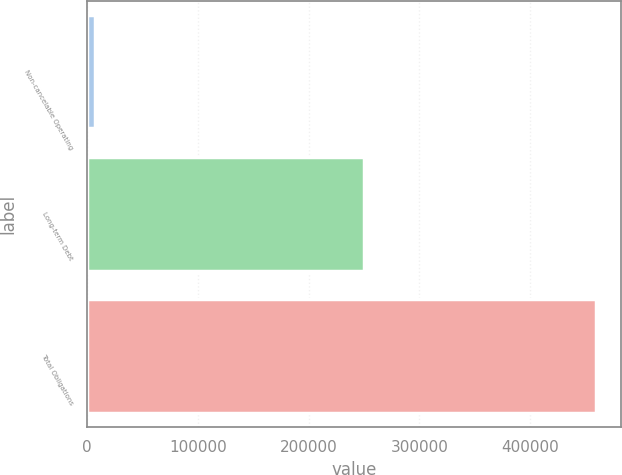Convert chart. <chart><loc_0><loc_0><loc_500><loc_500><bar_chart><fcel>Non-cancelable Operating<fcel>Long-term Debt<fcel>Total Obligations<nl><fcel>7551<fcel>250071<fcel>459322<nl></chart> 